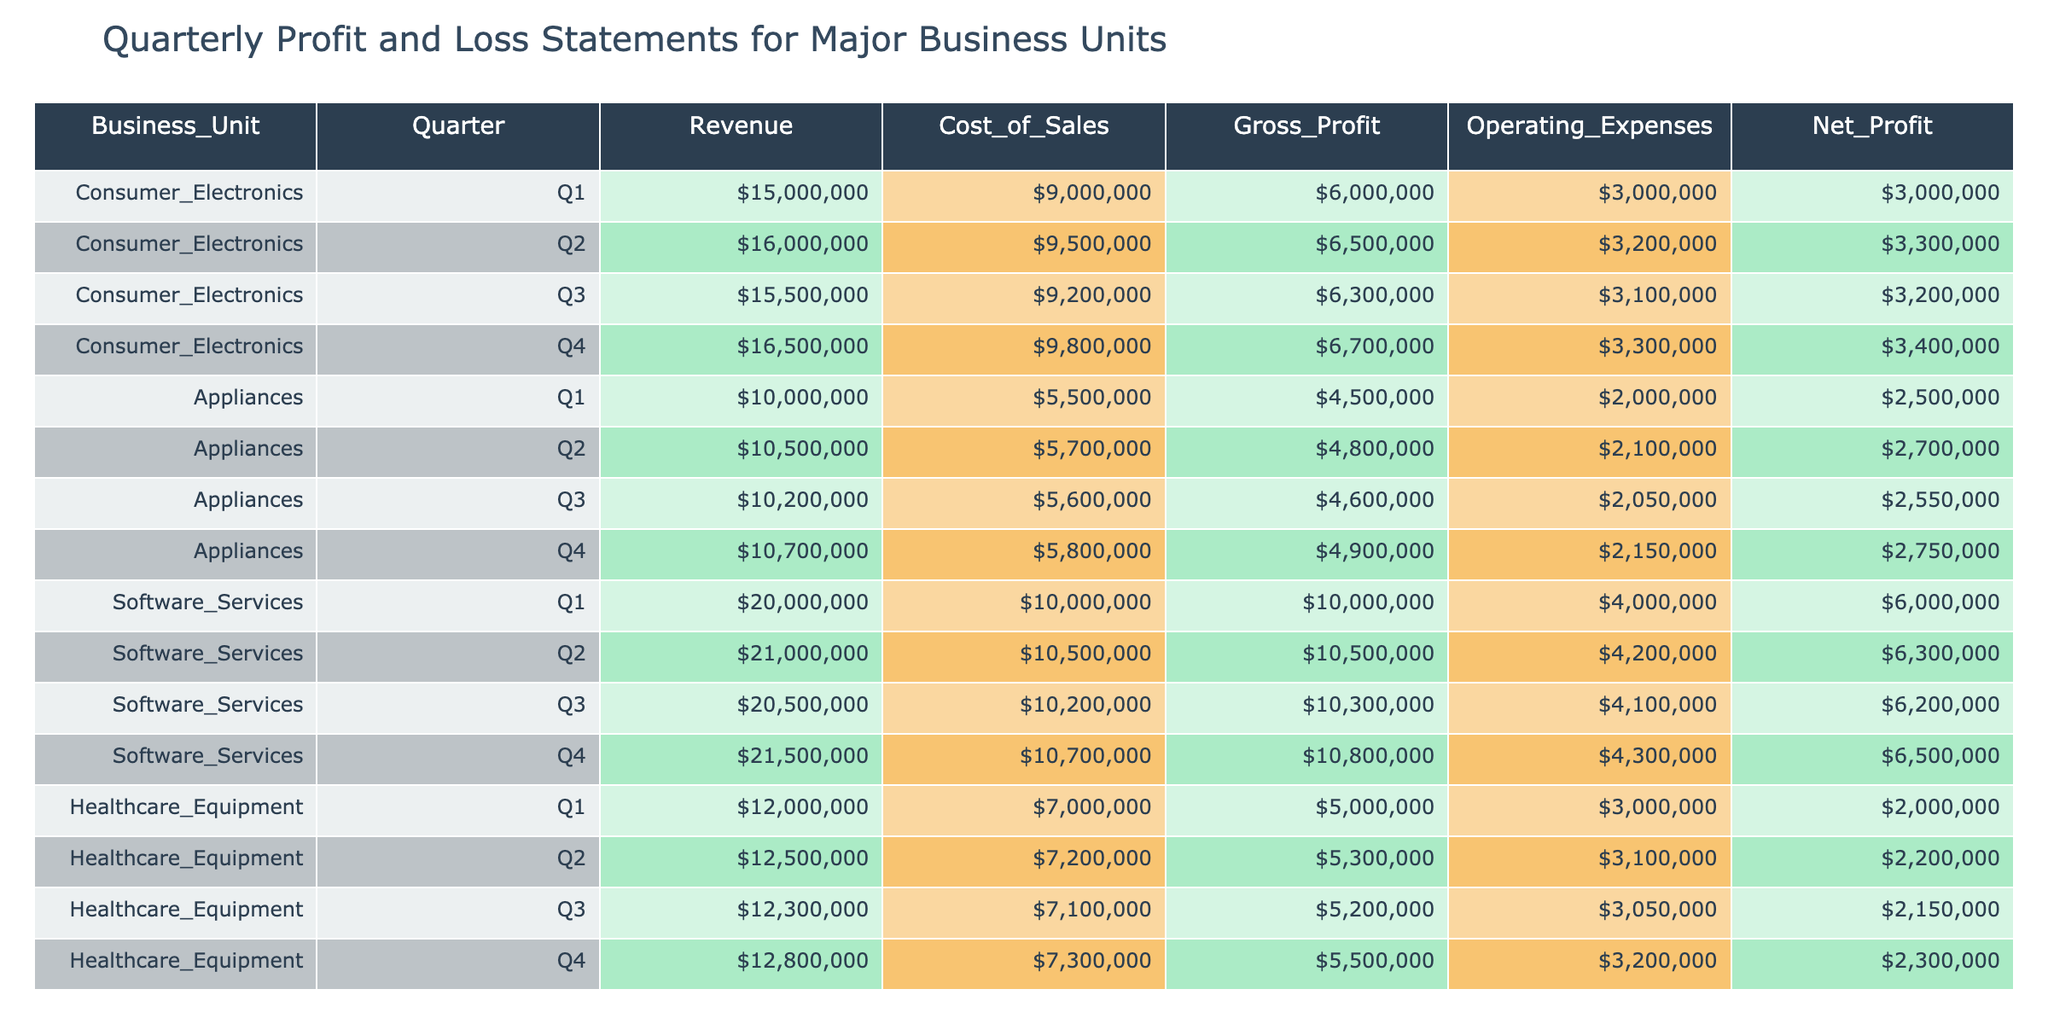What was the net profit for the Consumer Electronics unit in Q3? The net profit is found in the row corresponding to Consumer Electronics and Q3. According to the table, the net profit for that quarter is $3,200,000.
Answer: $3,200,000 Which business unit had the highest net profit in Q4? To find this, look at the net profit values for each business unit in Q4: Consumer Electronics ($3,400,000), Appliances ($2,750,000), Software Services ($6,500,000), and Healthcare Equipment ($2,300,000). The highest is for Software Services.
Answer: Software Services What is the total revenue for Appliances across all quarters? The revenues for Appliances are: Q1 ($10,000,000), Q2 ($10,500,000), Q3 ($10,200,000), and Q4 ($10,700,000). Summing these gives $10,000,000 + $10,500,000 + $10,200,000 + $10,700,000 = $41,400,000.
Answer: $41,400,000 Did the Gross Profit for Software Services decline from Q1 to Q4? The Gross Profit for Software Services in Q1 is $10,000,000 and in Q4 is $10,800,000. Since $10,800,000 is greater than $10,000,000, it did not decline.
Answer: No What is the average Net Profit for Healthcare Equipment across all quarters? To calculate the average, add the Net Profit values for each quarter: Q1 ($2,000,000), Q2 ($2,200,000), Q3 ($2,150,000), and Q4 ($2,300,000). The sum is $2,000,000 + $2,200,000 + $2,150,000 + $2,300,000 = $8,650,000. There are 4 quarters, so the average is $8,650,000 / 4 = $2,162,500.
Answer: $2,162,500 Which quarter had the highest gross profit for Consumer Electronics? The gross profits for Consumer Electronics are: Q1 ($6,000,000), Q2 ($6,500,000), Q3 ($6,300,000), and Q4 ($6,700,000). The highest is in Q4 at $6,700,000.
Answer: Q4 What is the total cost of sales for Software Services across all quarters? The Cost of Sales for Software Services are: Q1 ($10,000,000), Q2 ($10,500,000), Q3 ($10,200,000), and Q4 ($10,700,000). Adding them gives $10,000,000 + $10,500,000 + $10,200,000 + $10,700,000 = $41,400,000.
Answer: $41,400,000 In which quarter did the Appliances unit show the lowest net profit? The net profits for Appliances are: Q1 ($2,500,000), Q2 ($2,700,000), Q3 ($2,550,000), and Q4 ($2,750,000). The lowest net profit is in Q1.
Answer: Q1 